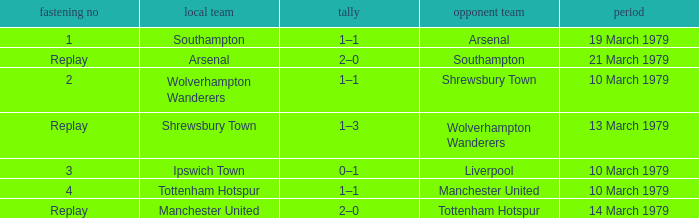What was the score for the tie that had Shrewsbury Town as home team? 1–3. 